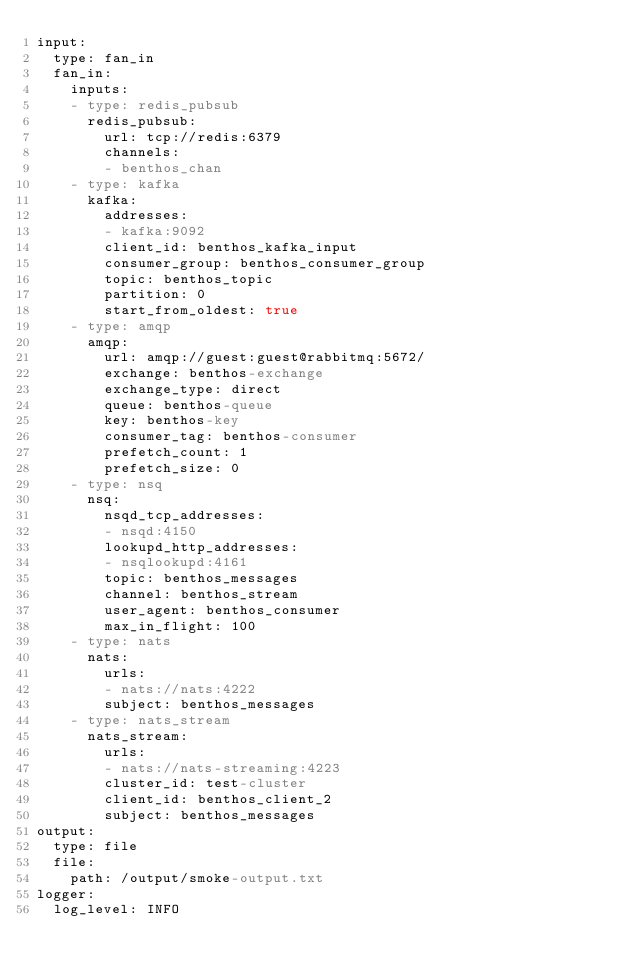Convert code to text. <code><loc_0><loc_0><loc_500><loc_500><_YAML_>input:
  type: fan_in
  fan_in:
    inputs:
    - type: redis_pubsub
      redis_pubsub:
        url: tcp://redis:6379
        channels:
        - benthos_chan
    - type: kafka
      kafka:
        addresses:
        - kafka:9092
        client_id: benthos_kafka_input
        consumer_group: benthos_consumer_group
        topic: benthos_topic
        partition: 0
        start_from_oldest: true
    - type: amqp
      amqp:
        url: amqp://guest:guest@rabbitmq:5672/
        exchange: benthos-exchange
        exchange_type: direct
        queue: benthos-queue
        key: benthos-key
        consumer_tag: benthos-consumer
        prefetch_count: 1
        prefetch_size: 0
    - type: nsq
      nsq:
        nsqd_tcp_addresses:
        - nsqd:4150
        lookupd_http_addresses:
        - nsqlookupd:4161
        topic: benthos_messages
        channel: benthos_stream
        user_agent: benthos_consumer
        max_in_flight: 100
    - type: nats
      nats:
        urls:
        - nats://nats:4222
        subject: benthos_messages
    - type: nats_stream
      nats_stream:
        urls:
        - nats://nats-streaming:4223
        cluster_id: test-cluster
        client_id: benthos_client_2
        subject: benthos_messages
output:
  type: file
  file:
    path: /output/smoke-output.txt
logger:
  log_level: INFO
</code> 